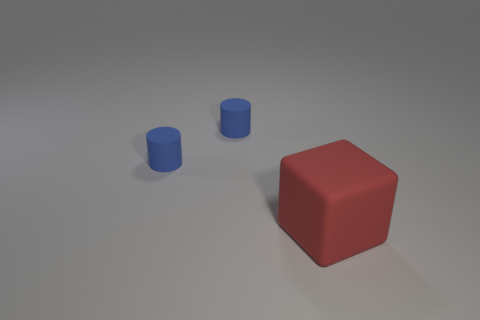The big object is what shape? cube 